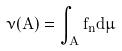Convert formula to latex. <formula><loc_0><loc_0><loc_500><loc_500>\nu ( A ) = \int _ { A } f _ { n } d \mu</formula> 